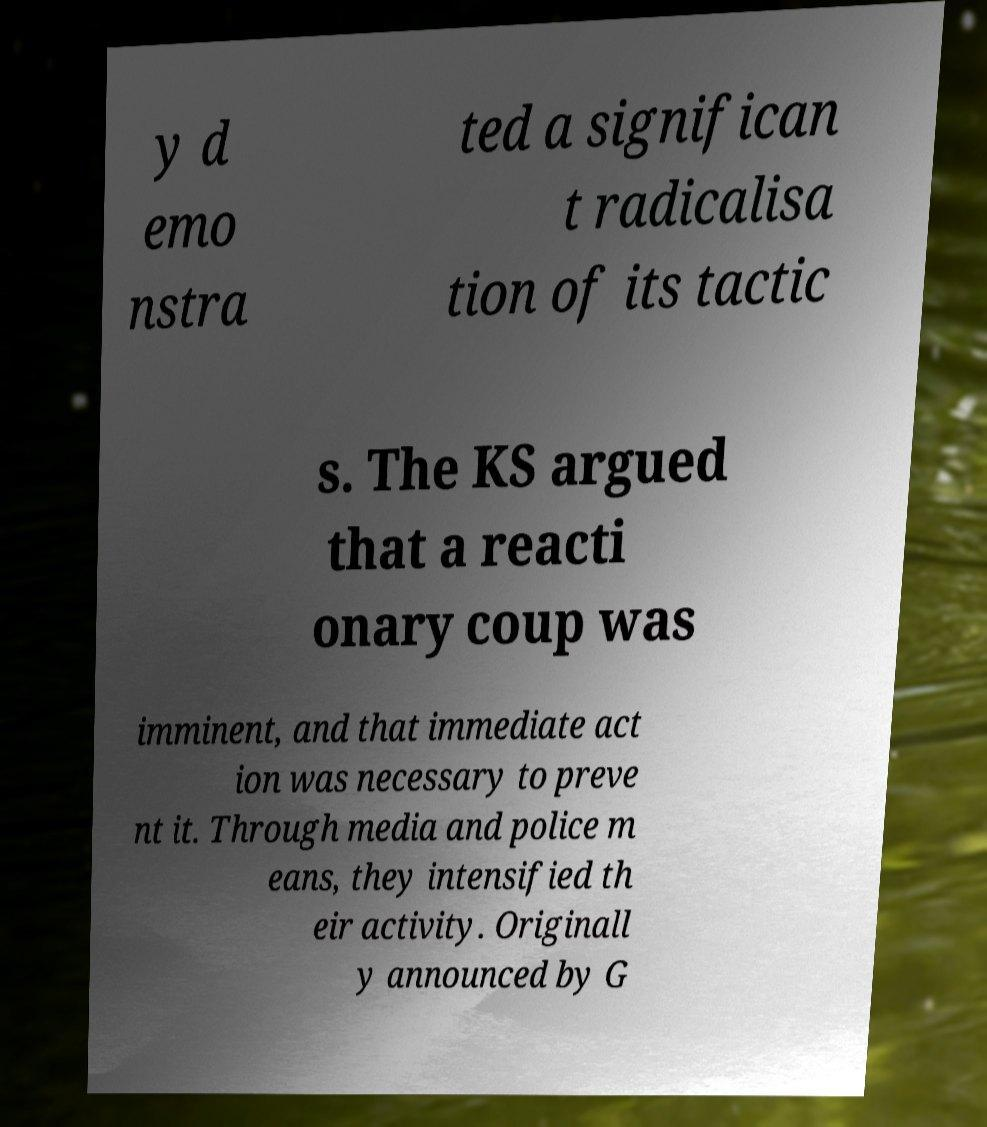I need the written content from this picture converted into text. Can you do that? y d emo nstra ted a significan t radicalisa tion of its tactic s. The KS argued that a reacti onary coup was imminent, and that immediate act ion was necessary to preve nt it. Through media and police m eans, they intensified th eir activity. Originall y announced by G 